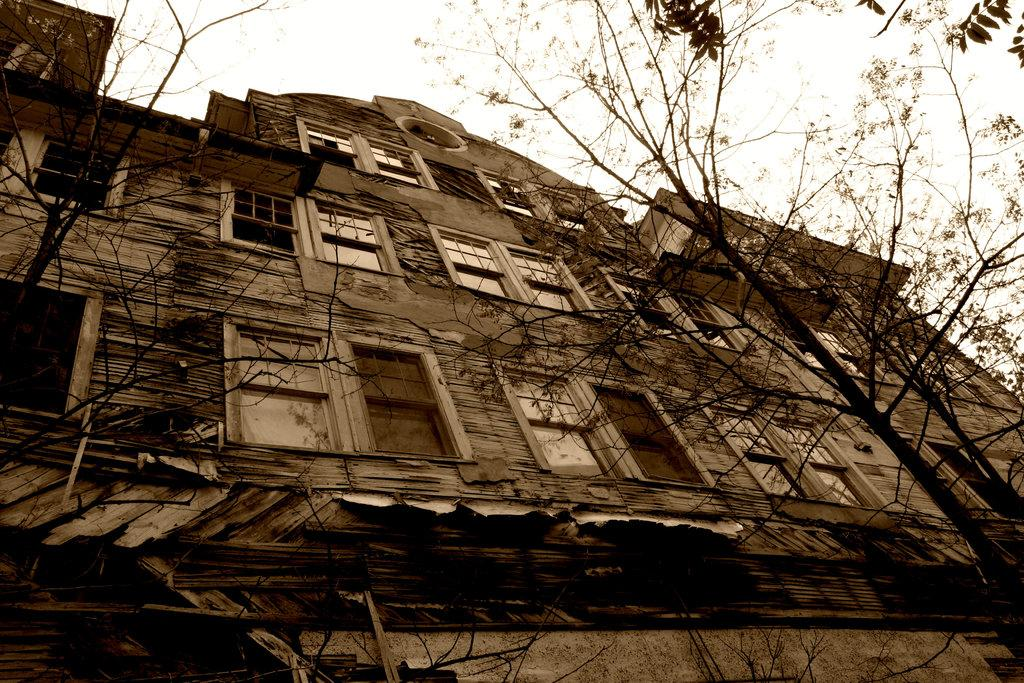What type of structure is present in the image? There is a building in the image. What can be seen on the right side of the image? There are trees on the right side of the image. What is visible at the top of the image? The sky is visible at the top of the image. How many men are participating in the show in the image? There is no show or men present in the image. What type of voyage is depicted in the image? There is no voyage depicted in the image; it features a building, trees, and the sky. 